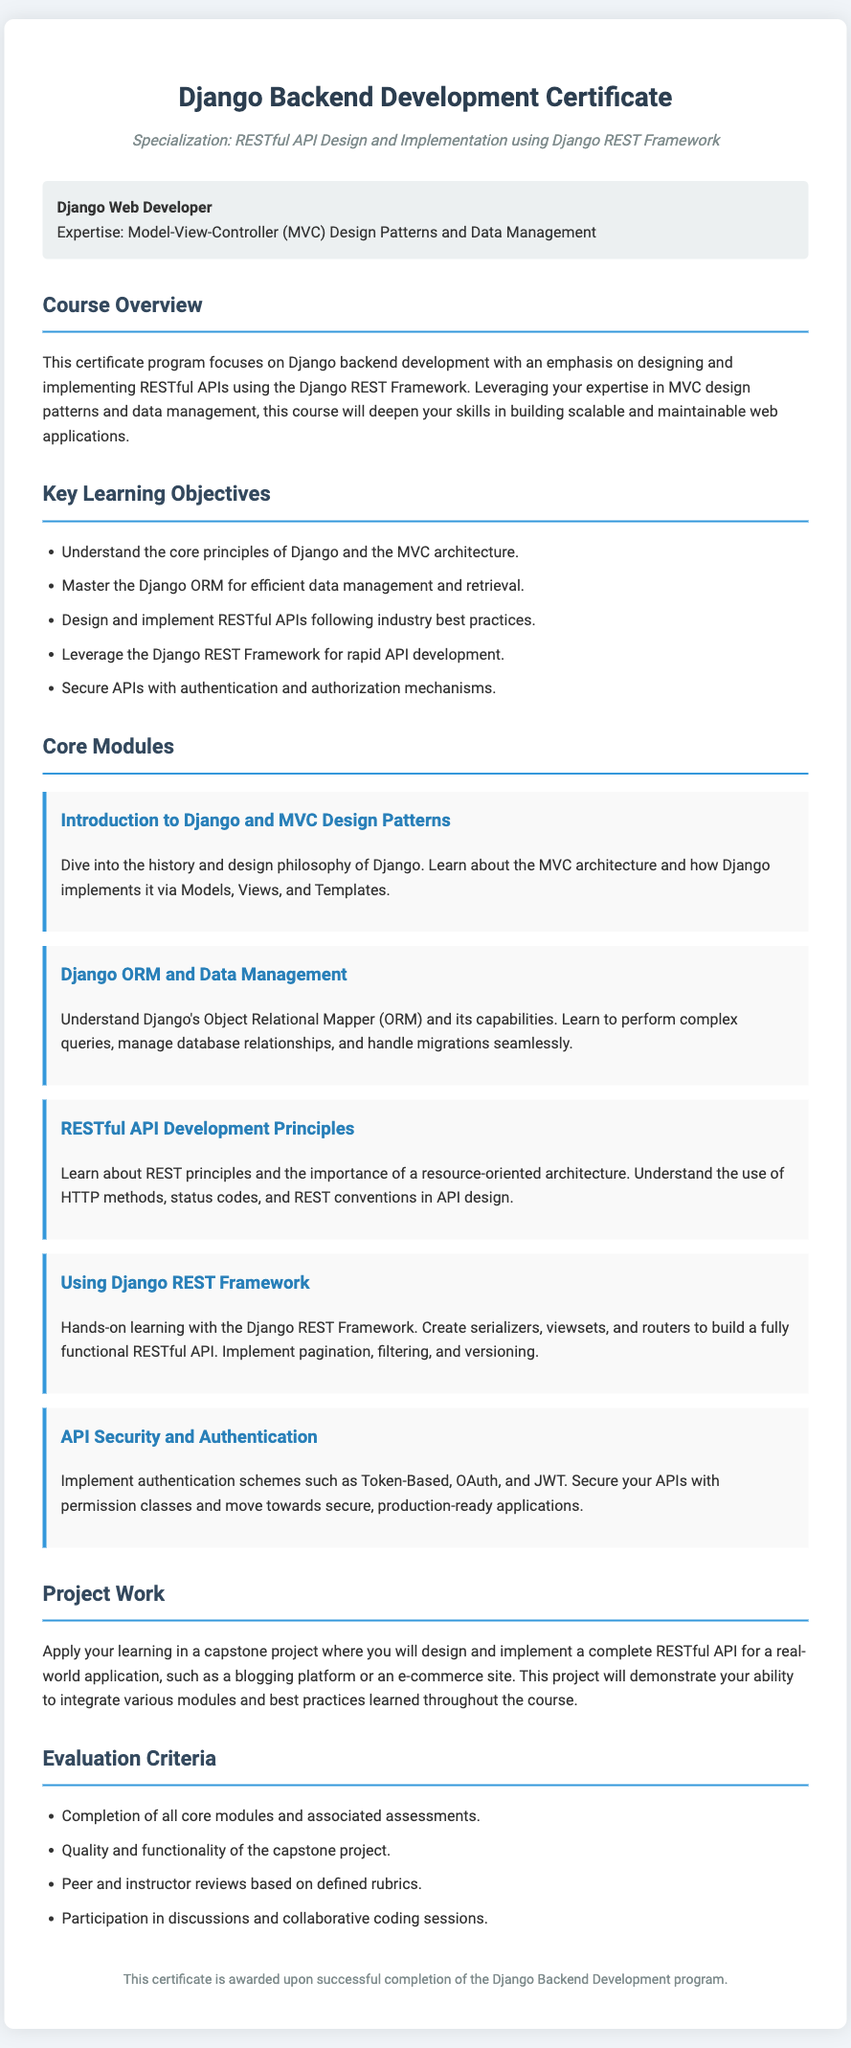What is the title of the certificate? The title of the certificate is prominently displayed at the top of the document.
Answer: Django Backend Development Certificate What is the specialization of the certificate? The specialization is mentioned under the title, highlighting the focus area of the course.
Answer: RESTful API Design and Implementation using Django REST Framework How many core modules are listed in the document? The document displays a section that outlines the core modules included in the course.
Answer: Five What is the first core module mentioned? The first core module is listed in the section detailing the course content.
Answer: Introduction to Django and MVC Design Patterns What type of project work is included in the course? The project work is described in a dedicated section, explaining its relevance to the overall course.
Answer: A capstone project What criteria are used for evaluation? The evaluation criteria are listed towards the end of the document, summarizing how progress is assessed.
Answer: Completion of all core modules and associated assessments Who is the target persona for this certificate? The document provides a specific description of the persona targeted by this certificate program.
Answer: Django Web Developer What security mechanisms are covered in the course? The section on API security specifies the types of security mechanisms that will be learned.
Answer: Token-Based, OAuth, and JWT What is the overarching theme of the course? The course overview describes the main focus and objectives of the program as a whole.
Answer: Django backend development with an emphasis on designing and implementing RESTful APIs 